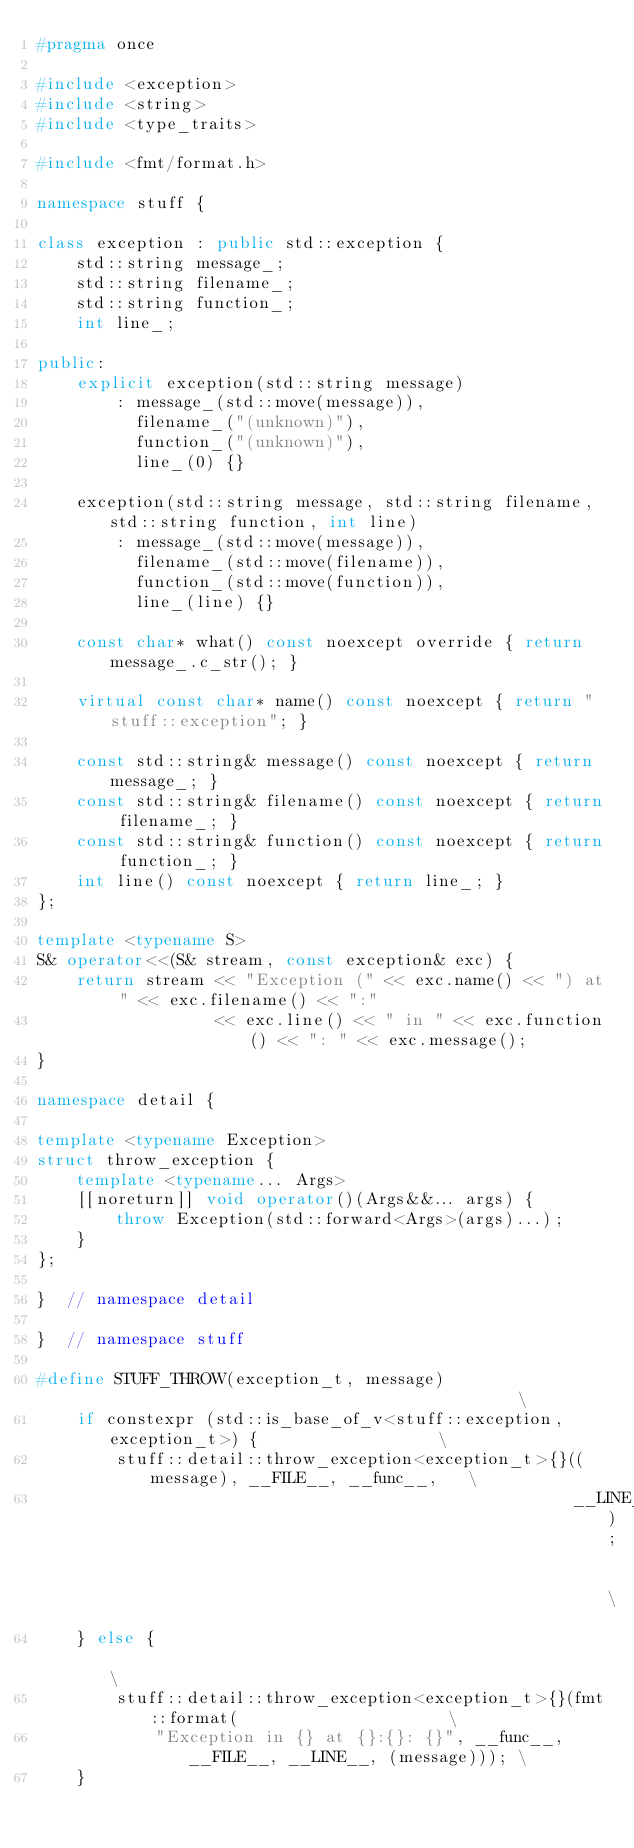<code> <loc_0><loc_0><loc_500><loc_500><_C++_>#pragma once

#include <exception>
#include <string>
#include <type_traits>

#include <fmt/format.h>

namespace stuff {

class exception : public std::exception {
    std::string message_;
    std::string filename_;
    std::string function_;
    int line_;

public:
    explicit exception(std::string message)
        : message_(std::move(message)),
          filename_("(unknown)"),
          function_("(unknown)"),
          line_(0) {}

    exception(std::string message, std::string filename, std::string function, int line)
        : message_(std::move(message)),
          filename_(std::move(filename)),
          function_(std::move(function)),
          line_(line) {}

    const char* what() const noexcept override { return message_.c_str(); }

    virtual const char* name() const noexcept { return "stuff::exception"; }

    const std::string& message() const noexcept { return message_; }
    const std::string& filename() const noexcept { return filename_; }
    const std::string& function() const noexcept { return function_; }
    int line() const noexcept { return line_; }
};

template <typename S>
S& operator<<(S& stream, const exception& exc) {
    return stream << "Exception (" << exc.name() << ") at " << exc.filename() << ":"
                  << exc.line() << " in " << exc.function() << ": " << exc.message();
}

namespace detail {

template <typename Exception>
struct throw_exception {
    template <typename... Args>
    [[noreturn]] void operator()(Args&&... args) {
        throw Exception(std::forward<Args>(args)...);
    }
};

}  // namespace detail

}  // namespace stuff

#define STUFF_THROW(exception_t, message)                                              \
    if constexpr (std::is_base_of_v<stuff::exception, exception_t>) {                  \
        stuff::detail::throw_exception<exception_t>{}((message), __FILE__, __func__,   \
                                                      __LINE__);                       \
    } else {                                                                           \
        stuff::detail::throw_exception<exception_t>{}(fmt::format(                     \
            "Exception in {} at {}:{}: {}", __func__, __FILE__, __LINE__, (message))); \
    }
</code> 